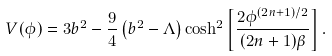Convert formula to latex. <formula><loc_0><loc_0><loc_500><loc_500>V ( \phi ) = 3 b ^ { 2 } - \frac { 9 } { 4 } \left ( b ^ { 2 } - \Lambda \right ) \cosh ^ { 2 } \left [ \frac { 2 \phi ^ { ( 2 n + 1 ) / 2 } } { ( 2 n + 1 ) \beta } \right ] .</formula> 